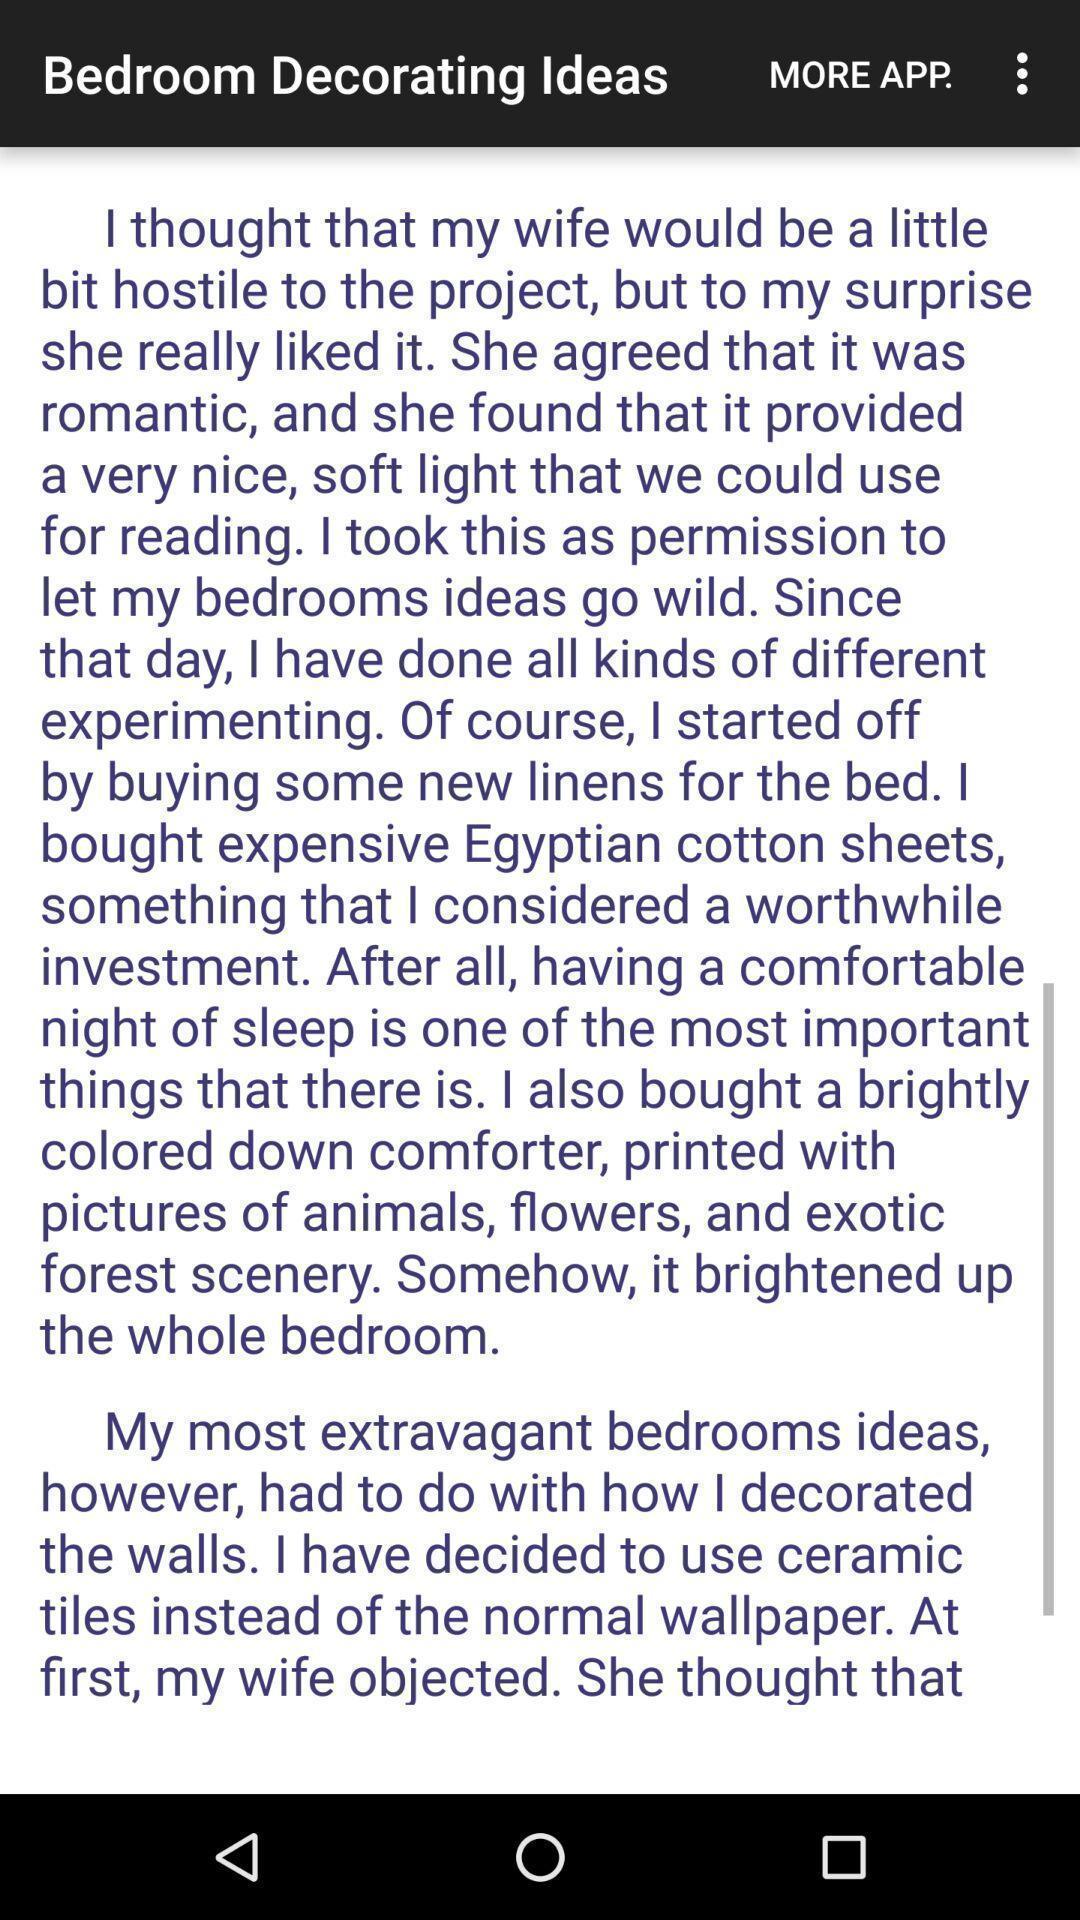Describe the key features of this screenshot. Screen shows bedroom decorating ideas. 